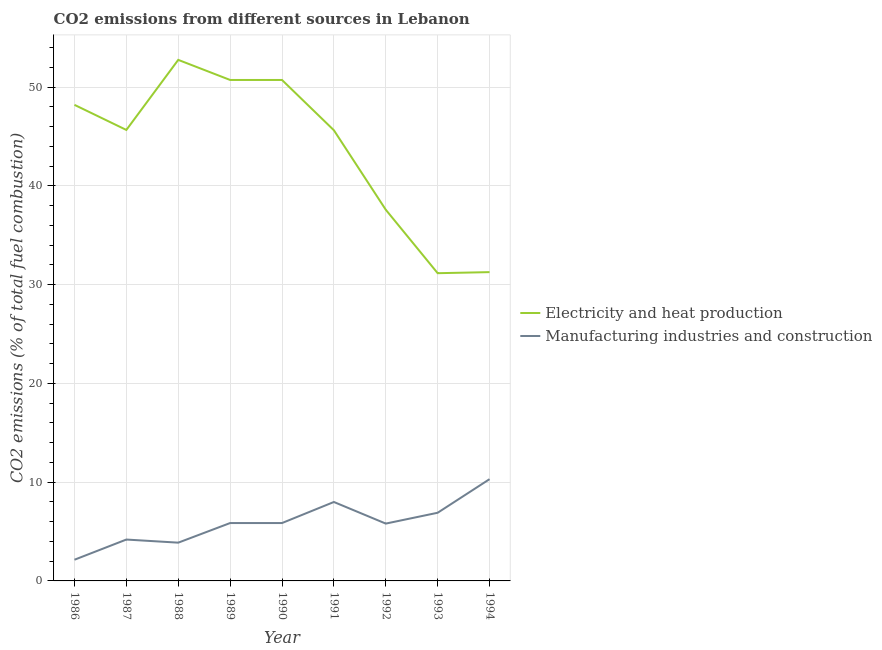How many different coloured lines are there?
Offer a very short reply. 2. Does the line corresponding to co2 emissions due to manufacturing industries intersect with the line corresponding to co2 emissions due to electricity and heat production?
Ensure brevity in your answer.  No. Is the number of lines equal to the number of legend labels?
Your answer should be very brief. Yes. What is the co2 emissions due to electricity and heat production in 1988?
Offer a terse response. 52.77. Across all years, what is the maximum co2 emissions due to manufacturing industries?
Give a very brief answer. 10.3. Across all years, what is the minimum co2 emissions due to electricity and heat production?
Your response must be concise. 31.16. What is the total co2 emissions due to electricity and heat production in the graph?
Give a very brief answer. 393.78. What is the difference between the co2 emissions due to electricity and heat production in 1991 and that in 1992?
Offer a very short reply. 8.05. What is the difference between the co2 emissions due to electricity and heat production in 1990 and the co2 emissions due to manufacturing industries in 1986?
Make the answer very short. 48.59. What is the average co2 emissions due to electricity and heat production per year?
Keep it short and to the point. 43.75. In the year 1994, what is the difference between the co2 emissions due to manufacturing industries and co2 emissions due to electricity and heat production?
Make the answer very short. -20.97. In how many years, is the co2 emissions due to electricity and heat production greater than 44 %?
Ensure brevity in your answer.  6. What is the ratio of the co2 emissions due to manufacturing industries in 1989 to that in 1993?
Provide a succinct answer. 0.85. Is the difference between the co2 emissions due to manufacturing industries in 1986 and 1992 greater than the difference between the co2 emissions due to electricity and heat production in 1986 and 1992?
Your response must be concise. No. What is the difference between the highest and the second highest co2 emissions due to electricity and heat production?
Provide a succinct answer. 2.03. What is the difference between the highest and the lowest co2 emissions due to electricity and heat production?
Provide a short and direct response. 21.6. In how many years, is the co2 emissions due to electricity and heat production greater than the average co2 emissions due to electricity and heat production taken over all years?
Give a very brief answer. 6. Is the sum of the co2 emissions due to manufacturing industries in 1990 and 1993 greater than the maximum co2 emissions due to electricity and heat production across all years?
Make the answer very short. No. Is the co2 emissions due to electricity and heat production strictly greater than the co2 emissions due to manufacturing industries over the years?
Your answer should be very brief. Yes. Is the co2 emissions due to electricity and heat production strictly less than the co2 emissions due to manufacturing industries over the years?
Ensure brevity in your answer.  No. Are the values on the major ticks of Y-axis written in scientific E-notation?
Your answer should be very brief. No. Does the graph contain grids?
Give a very brief answer. Yes. Where does the legend appear in the graph?
Make the answer very short. Center right. How are the legend labels stacked?
Your answer should be very brief. Vertical. What is the title of the graph?
Offer a terse response. CO2 emissions from different sources in Lebanon. What is the label or title of the X-axis?
Ensure brevity in your answer.  Year. What is the label or title of the Y-axis?
Your response must be concise. CO2 emissions (% of total fuel combustion). What is the CO2 emissions (% of total fuel combustion) of Electricity and heat production in 1986?
Provide a short and direct response. 48.21. What is the CO2 emissions (% of total fuel combustion) of Manufacturing industries and construction in 1986?
Your response must be concise. 2.15. What is the CO2 emissions (% of total fuel combustion) in Electricity and heat production in 1987?
Offer a terse response. 45.67. What is the CO2 emissions (% of total fuel combustion) of Manufacturing industries and construction in 1987?
Your answer should be very brief. 4.19. What is the CO2 emissions (% of total fuel combustion) of Electricity and heat production in 1988?
Provide a succinct answer. 52.77. What is the CO2 emissions (% of total fuel combustion) in Manufacturing industries and construction in 1988?
Your answer should be compact. 3.87. What is the CO2 emissions (% of total fuel combustion) in Electricity and heat production in 1989?
Your answer should be compact. 50.73. What is the CO2 emissions (% of total fuel combustion) of Manufacturing industries and construction in 1989?
Offer a terse response. 5.86. What is the CO2 emissions (% of total fuel combustion) of Electricity and heat production in 1990?
Make the answer very short. 50.73. What is the CO2 emissions (% of total fuel combustion) in Manufacturing industries and construction in 1990?
Offer a very short reply. 5.86. What is the CO2 emissions (% of total fuel combustion) of Electricity and heat production in 1991?
Offer a very short reply. 45.64. What is the CO2 emissions (% of total fuel combustion) in Manufacturing industries and construction in 1991?
Offer a terse response. 7.99. What is the CO2 emissions (% of total fuel combustion) of Electricity and heat production in 1992?
Give a very brief answer. 37.59. What is the CO2 emissions (% of total fuel combustion) in Manufacturing industries and construction in 1992?
Your answer should be very brief. 5.81. What is the CO2 emissions (% of total fuel combustion) in Electricity and heat production in 1993?
Your response must be concise. 31.16. What is the CO2 emissions (% of total fuel combustion) in Manufacturing industries and construction in 1993?
Keep it short and to the point. 6.9. What is the CO2 emissions (% of total fuel combustion) in Electricity and heat production in 1994?
Keep it short and to the point. 31.27. What is the CO2 emissions (% of total fuel combustion) of Manufacturing industries and construction in 1994?
Your answer should be compact. 10.3. Across all years, what is the maximum CO2 emissions (% of total fuel combustion) of Electricity and heat production?
Offer a terse response. 52.77. Across all years, what is the maximum CO2 emissions (% of total fuel combustion) in Manufacturing industries and construction?
Provide a short and direct response. 10.3. Across all years, what is the minimum CO2 emissions (% of total fuel combustion) in Electricity and heat production?
Offer a very short reply. 31.16. Across all years, what is the minimum CO2 emissions (% of total fuel combustion) in Manufacturing industries and construction?
Make the answer very short. 2.15. What is the total CO2 emissions (% of total fuel combustion) of Electricity and heat production in the graph?
Provide a short and direct response. 393.78. What is the total CO2 emissions (% of total fuel combustion) of Manufacturing industries and construction in the graph?
Provide a short and direct response. 52.94. What is the difference between the CO2 emissions (% of total fuel combustion) of Electricity and heat production in 1986 and that in 1987?
Make the answer very short. 2.54. What is the difference between the CO2 emissions (% of total fuel combustion) of Manufacturing industries and construction in 1986 and that in 1987?
Your response must be concise. -2.04. What is the difference between the CO2 emissions (% of total fuel combustion) of Electricity and heat production in 1986 and that in 1988?
Provide a succinct answer. -4.56. What is the difference between the CO2 emissions (% of total fuel combustion) in Manufacturing industries and construction in 1986 and that in 1988?
Your answer should be very brief. -1.73. What is the difference between the CO2 emissions (% of total fuel combustion) of Electricity and heat production in 1986 and that in 1989?
Keep it short and to the point. -2.52. What is the difference between the CO2 emissions (% of total fuel combustion) of Manufacturing industries and construction in 1986 and that in 1989?
Your answer should be compact. -3.71. What is the difference between the CO2 emissions (% of total fuel combustion) of Electricity and heat production in 1986 and that in 1990?
Your response must be concise. -2.52. What is the difference between the CO2 emissions (% of total fuel combustion) of Manufacturing industries and construction in 1986 and that in 1990?
Give a very brief answer. -3.71. What is the difference between the CO2 emissions (% of total fuel combustion) of Electricity and heat production in 1986 and that in 1991?
Your response must be concise. 2.57. What is the difference between the CO2 emissions (% of total fuel combustion) of Manufacturing industries and construction in 1986 and that in 1991?
Ensure brevity in your answer.  -5.85. What is the difference between the CO2 emissions (% of total fuel combustion) of Electricity and heat production in 1986 and that in 1992?
Your response must be concise. 10.62. What is the difference between the CO2 emissions (% of total fuel combustion) of Manufacturing industries and construction in 1986 and that in 1992?
Your answer should be compact. -3.66. What is the difference between the CO2 emissions (% of total fuel combustion) in Electricity and heat production in 1986 and that in 1993?
Ensure brevity in your answer.  17.05. What is the difference between the CO2 emissions (% of total fuel combustion) in Manufacturing industries and construction in 1986 and that in 1993?
Ensure brevity in your answer.  -4.76. What is the difference between the CO2 emissions (% of total fuel combustion) in Electricity and heat production in 1986 and that in 1994?
Your answer should be compact. 16.94. What is the difference between the CO2 emissions (% of total fuel combustion) in Manufacturing industries and construction in 1986 and that in 1994?
Give a very brief answer. -8.16. What is the difference between the CO2 emissions (% of total fuel combustion) of Electricity and heat production in 1987 and that in 1988?
Provide a short and direct response. -7.1. What is the difference between the CO2 emissions (% of total fuel combustion) in Manufacturing industries and construction in 1987 and that in 1988?
Keep it short and to the point. 0.32. What is the difference between the CO2 emissions (% of total fuel combustion) in Electricity and heat production in 1987 and that in 1989?
Your answer should be very brief. -5.06. What is the difference between the CO2 emissions (% of total fuel combustion) of Manufacturing industries and construction in 1987 and that in 1989?
Offer a very short reply. -1.67. What is the difference between the CO2 emissions (% of total fuel combustion) in Electricity and heat production in 1987 and that in 1990?
Your answer should be very brief. -5.06. What is the difference between the CO2 emissions (% of total fuel combustion) of Manufacturing industries and construction in 1987 and that in 1990?
Provide a succinct answer. -1.67. What is the difference between the CO2 emissions (% of total fuel combustion) of Electricity and heat production in 1987 and that in 1991?
Your answer should be compact. 0.03. What is the difference between the CO2 emissions (% of total fuel combustion) in Manufacturing industries and construction in 1987 and that in 1991?
Keep it short and to the point. -3.8. What is the difference between the CO2 emissions (% of total fuel combustion) of Electricity and heat production in 1987 and that in 1992?
Offer a very short reply. 8.08. What is the difference between the CO2 emissions (% of total fuel combustion) in Manufacturing industries and construction in 1987 and that in 1992?
Your answer should be very brief. -1.62. What is the difference between the CO2 emissions (% of total fuel combustion) in Electricity and heat production in 1987 and that in 1993?
Your response must be concise. 14.51. What is the difference between the CO2 emissions (% of total fuel combustion) in Manufacturing industries and construction in 1987 and that in 1993?
Your answer should be very brief. -2.71. What is the difference between the CO2 emissions (% of total fuel combustion) in Electricity and heat production in 1987 and that in 1994?
Your answer should be very brief. 14.4. What is the difference between the CO2 emissions (% of total fuel combustion) in Manufacturing industries and construction in 1987 and that in 1994?
Your answer should be very brief. -6.11. What is the difference between the CO2 emissions (% of total fuel combustion) in Electricity and heat production in 1988 and that in 1989?
Provide a short and direct response. 2.03. What is the difference between the CO2 emissions (% of total fuel combustion) in Manufacturing industries and construction in 1988 and that in 1989?
Your answer should be very brief. -1.99. What is the difference between the CO2 emissions (% of total fuel combustion) in Electricity and heat production in 1988 and that in 1990?
Give a very brief answer. 2.03. What is the difference between the CO2 emissions (% of total fuel combustion) of Manufacturing industries and construction in 1988 and that in 1990?
Offer a very short reply. -1.99. What is the difference between the CO2 emissions (% of total fuel combustion) in Electricity and heat production in 1988 and that in 1991?
Offer a very short reply. 7.13. What is the difference between the CO2 emissions (% of total fuel combustion) of Manufacturing industries and construction in 1988 and that in 1991?
Offer a very short reply. -4.12. What is the difference between the CO2 emissions (% of total fuel combustion) of Electricity and heat production in 1988 and that in 1992?
Ensure brevity in your answer.  15.18. What is the difference between the CO2 emissions (% of total fuel combustion) of Manufacturing industries and construction in 1988 and that in 1992?
Give a very brief answer. -1.93. What is the difference between the CO2 emissions (% of total fuel combustion) in Electricity and heat production in 1988 and that in 1993?
Keep it short and to the point. 21.6. What is the difference between the CO2 emissions (% of total fuel combustion) in Manufacturing industries and construction in 1988 and that in 1993?
Your response must be concise. -3.03. What is the difference between the CO2 emissions (% of total fuel combustion) of Electricity and heat production in 1988 and that in 1994?
Provide a short and direct response. 21.5. What is the difference between the CO2 emissions (% of total fuel combustion) of Manufacturing industries and construction in 1988 and that in 1994?
Offer a very short reply. -6.43. What is the difference between the CO2 emissions (% of total fuel combustion) of Electricity and heat production in 1989 and that in 1991?
Give a very brief answer. 5.09. What is the difference between the CO2 emissions (% of total fuel combustion) of Manufacturing industries and construction in 1989 and that in 1991?
Give a very brief answer. -2.13. What is the difference between the CO2 emissions (% of total fuel combustion) of Electricity and heat production in 1989 and that in 1992?
Give a very brief answer. 13.14. What is the difference between the CO2 emissions (% of total fuel combustion) of Manufacturing industries and construction in 1989 and that in 1992?
Provide a succinct answer. 0.06. What is the difference between the CO2 emissions (% of total fuel combustion) of Electricity and heat production in 1989 and that in 1993?
Give a very brief answer. 19.57. What is the difference between the CO2 emissions (% of total fuel combustion) in Manufacturing industries and construction in 1989 and that in 1993?
Your answer should be very brief. -1.04. What is the difference between the CO2 emissions (% of total fuel combustion) in Electricity and heat production in 1989 and that in 1994?
Your answer should be very brief. 19.46. What is the difference between the CO2 emissions (% of total fuel combustion) of Manufacturing industries and construction in 1989 and that in 1994?
Provide a short and direct response. -4.44. What is the difference between the CO2 emissions (% of total fuel combustion) of Electricity and heat production in 1990 and that in 1991?
Offer a very short reply. 5.09. What is the difference between the CO2 emissions (% of total fuel combustion) in Manufacturing industries and construction in 1990 and that in 1991?
Give a very brief answer. -2.13. What is the difference between the CO2 emissions (% of total fuel combustion) of Electricity and heat production in 1990 and that in 1992?
Make the answer very short. 13.14. What is the difference between the CO2 emissions (% of total fuel combustion) of Manufacturing industries and construction in 1990 and that in 1992?
Provide a succinct answer. 0.06. What is the difference between the CO2 emissions (% of total fuel combustion) in Electricity and heat production in 1990 and that in 1993?
Your response must be concise. 19.57. What is the difference between the CO2 emissions (% of total fuel combustion) of Manufacturing industries and construction in 1990 and that in 1993?
Your answer should be compact. -1.04. What is the difference between the CO2 emissions (% of total fuel combustion) in Electricity and heat production in 1990 and that in 1994?
Your answer should be very brief. 19.46. What is the difference between the CO2 emissions (% of total fuel combustion) in Manufacturing industries and construction in 1990 and that in 1994?
Give a very brief answer. -4.44. What is the difference between the CO2 emissions (% of total fuel combustion) in Electricity and heat production in 1991 and that in 1992?
Your response must be concise. 8.05. What is the difference between the CO2 emissions (% of total fuel combustion) of Manufacturing industries and construction in 1991 and that in 1992?
Keep it short and to the point. 2.19. What is the difference between the CO2 emissions (% of total fuel combustion) of Electricity and heat production in 1991 and that in 1993?
Make the answer very short. 14.48. What is the difference between the CO2 emissions (% of total fuel combustion) of Manufacturing industries and construction in 1991 and that in 1993?
Provide a succinct answer. 1.09. What is the difference between the CO2 emissions (% of total fuel combustion) of Electricity and heat production in 1991 and that in 1994?
Your answer should be very brief. 14.37. What is the difference between the CO2 emissions (% of total fuel combustion) of Manufacturing industries and construction in 1991 and that in 1994?
Offer a very short reply. -2.31. What is the difference between the CO2 emissions (% of total fuel combustion) in Electricity and heat production in 1992 and that in 1993?
Your answer should be compact. 6.43. What is the difference between the CO2 emissions (% of total fuel combustion) of Manufacturing industries and construction in 1992 and that in 1993?
Keep it short and to the point. -1.1. What is the difference between the CO2 emissions (% of total fuel combustion) in Electricity and heat production in 1992 and that in 1994?
Your answer should be compact. 6.32. What is the difference between the CO2 emissions (% of total fuel combustion) of Manufacturing industries and construction in 1992 and that in 1994?
Offer a terse response. -4.5. What is the difference between the CO2 emissions (% of total fuel combustion) of Electricity and heat production in 1993 and that in 1994?
Provide a succinct answer. -0.11. What is the difference between the CO2 emissions (% of total fuel combustion) of Manufacturing industries and construction in 1993 and that in 1994?
Provide a short and direct response. -3.4. What is the difference between the CO2 emissions (% of total fuel combustion) of Electricity and heat production in 1986 and the CO2 emissions (% of total fuel combustion) of Manufacturing industries and construction in 1987?
Ensure brevity in your answer.  44.02. What is the difference between the CO2 emissions (% of total fuel combustion) of Electricity and heat production in 1986 and the CO2 emissions (% of total fuel combustion) of Manufacturing industries and construction in 1988?
Keep it short and to the point. 44.34. What is the difference between the CO2 emissions (% of total fuel combustion) of Electricity and heat production in 1986 and the CO2 emissions (% of total fuel combustion) of Manufacturing industries and construction in 1989?
Offer a very short reply. 42.35. What is the difference between the CO2 emissions (% of total fuel combustion) of Electricity and heat production in 1986 and the CO2 emissions (% of total fuel combustion) of Manufacturing industries and construction in 1990?
Offer a terse response. 42.35. What is the difference between the CO2 emissions (% of total fuel combustion) of Electricity and heat production in 1986 and the CO2 emissions (% of total fuel combustion) of Manufacturing industries and construction in 1991?
Your answer should be compact. 40.22. What is the difference between the CO2 emissions (% of total fuel combustion) in Electricity and heat production in 1986 and the CO2 emissions (% of total fuel combustion) in Manufacturing industries and construction in 1992?
Keep it short and to the point. 42.41. What is the difference between the CO2 emissions (% of total fuel combustion) in Electricity and heat production in 1986 and the CO2 emissions (% of total fuel combustion) in Manufacturing industries and construction in 1993?
Ensure brevity in your answer.  41.31. What is the difference between the CO2 emissions (% of total fuel combustion) in Electricity and heat production in 1986 and the CO2 emissions (% of total fuel combustion) in Manufacturing industries and construction in 1994?
Offer a very short reply. 37.91. What is the difference between the CO2 emissions (% of total fuel combustion) of Electricity and heat production in 1987 and the CO2 emissions (% of total fuel combustion) of Manufacturing industries and construction in 1988?
Offer a very short reply. 41.8. What is the difference between the CO2 emissions (% of total fuel combustion) in Electricity and heat production in 1987 and the CO2 emissions (% of total fuel combustion) in Manufacturing industries and construction in 1989?
Give a very brief answer. 39.81. What is the difference between the CO2 emissions (% of total fuel combustion) in Electricity and heat production in 1987 and the CO2 emissions (% of total fuel combustion) in Manufacturing industries and construction in 1990?
Make the answer very short. 39.81. What is the difference between the CO2 emissions (% of total fuel combustion) in Electricity and heat production in 1987 and the CO2 emissions (% of total fuel combustion) in Manufacturing industries and construction in 1991?
Provide a succinct answer. 37.68. What is the difference between the CO2 emissions (% of total fuel combustion) in Electricity and heat production in 1987 and the CO2 emissions (% of total fuel combustion) in Manufacturing industries and construction in 1992?
Your answer should be very brief. 39.86. What is the difference between the CO2 emissions (% of total fuel combustion) in Electricity and heat production in 1987 and the CO2 emissions (% of total fuel combustion) in Manufacturing industries and construction in 1993?
Keep it short and to the point. 38.77. What is the difference between the CO2 emissions (% of total fuel combustion) of Electricity and heat production in 1987 and the CO2 emissions (% of total fuel combustion) of Manufacturing industries and construction in 1994?
Give a very brief answer. 35.37. What is the difference between the CO2 emissions (% of total fuel combustion) of Electricity and heat production in 1988 and the CO2 emissions (% of total fuel combustion) of Manufacturing industries and construction in 1989?
Your response must be concise. 46.91. What is the difference between the CO2 emissions (% of total fuel combustion) in Electricity and heat production in 1988 and the CO2 emissions (% of total fuel combustion) in Manufacturing industries and construction in 1990?
Provide a succinct answer. 46.91. What is the difference between the CO2 emissions (% of total fuel combustion) of Electricity and heat production in 1988 and the CO2 emissions (% of total fuel combustion) of Manufacturing industries and construction in 1991?
Make the answer very short. 44.77. What is the difference between the CO2 emissions (% of total fuel combustion) in Electricity and heat production in 1988 and the CO2 emissions (% of total fuel combustion) in Manufacturing industries and construction in 1992?
Offer a terse response. 46.96. What is the difference between the CO2 emissions (% of total fuel combustion) in Electricity and heat production in 1988 and the CO2 emissions (% of total fuel combustion) in Manufacturing industries and construction in 1993?
Ensure brevity in your answer.  45.86. What is the difference between the CO2 emissions (% of total fuel combustion) in Electricity and heat production in 1988 and the CO2 emissions (% of total fuel combustion) in Manufacturing industries and construction in 1994?
Give a very brief answer. 42.46. What is the difference between the CO2 emissions (% of total fuel combustion) of Electricity and heat production in 1989 and the CO2 emissions (% of total fuel combustion) of Manufacturing industries and construction in 1990?
Your answer should be compact. 44.87. What is the difference between the CO2 emissions (% of total fuel combustion) in Electricity and heat production in 1989 and the CO2 emissions (% of total fuel combustion) in Manufacturing industries and construction in 1991?
Keep it short and to the point. 42.74. What is the difference between the CO2 emissions (% of total fuel combustion) of Electricity and heat production in 1989 and the CO2 emissions (% of total fuel combustion) of Manufacturing industries and construction in 1992?
Your answer should be compact. 44.93. What is the difference between the CO2 emissions (% of total fuel combustion) in Electricity and heat production in 1989 and the CO2 emissions (% of total fuel combustion) in Manufacturing industries and construction in 1993?
Your response must be concise. 43.83. What is the difference between the CO2 emissions (% of total fuel combustion) of Electricity and heat production in 1989 and the CO2 emissions (% of total fuel combustion) of Manufacturing industries and construction in 1994?
Your response must be concise. 40.43. What is the difference between the CO2 emissions (% of total fuel combustion) in Electricity and heat production in 1990 and the CO2 emissions (% of total fuel combustion) in Manufacturing industries and construction in 1991?
Offer a very short reply. 42.74. What is the difference between the CO2 emissions (% of total fuel combustion) in Electricity and heat production in 1990 and the CO2 emissions (% of total fuel combustion) in Manufacturing industries and construction in 1992?
Ensure brevity in your answer.  44.93. What is the difference between the CO2 emissions (% of total fuel combustion) in Electricity and heat production in 1990 and the CO2 emissions (% of total fuel combustion) in Manufacturing industries and construction in 1993?
Give a very brief answer. 43.83. What is the difference between the CO2 emissions (% of total fuel combustion) of Electricity and heat production in 1990 and the CO2 emissions (% of total fuel combustion) of Manufacturing industries and construction in 1994?
Provide a short and direct response. 40.43. What is the difference between the CO2 emissions (% of total fuel combustion) in Electricity and heat production in 1991 and the CO2 emissions (% of total fuel combustion) in Manufacturing industries and construction in 1992?
Ensure brevity in your answer.  39.83. What is the difference between the CO2 emissions (% of total fuel combustion) of Electricity and heat production in 1991 and the CO2 emissions (% of total fuel combustion) of Manufacturing industries and construction in 1993?
Keep it short and to the point. 38.74. What is the difference between the CO2 emissions (% of total fuel combustion) in Electricity and heat production in 1991 and the CO2 emissions (% of total fuel combustion) in Manufacturing industries and construction in 1994?
Your answer should be very brief. 35.33. What is the difference between the CO2 emissions (% of total fuel combustion) of Electricity and heat production in 1992 and the CO2 emissions (% of total fuel combustion) of Manufacturing industries and construction in 1993?
Provide a short and direct response. 30.69. What is the difference between the CO2 emissions (% of total fuel combustion) of Electricity and heat production in 1992 and the CO2 emissions (% of total fuel combustion) of Manufacturing industries and construction in 1994?
Ensure brevity in your answer.  27.29. What is the difference between the CO2 emissions (% of total fuel combustion) in Electricity and heat production in 1993 and the CO2 emissions (% of total fuel combustion) in Manufacturing industries and construction in 1994?
Your answer should be very brief. 20.86. What is the average CO2 emissions (% of total fuel combustion) of Electricity and heat production per year?
Your answer should be compact. 43.75. What is the average CO2 emissions (% of total fuel combustion) of Manufacturing industries and construction per year?
Provide a short and direct response. 5.88. In the year 1986, what is the difference between the CO2 emissions (% of total fuel combustion) in Electricity and heat production and CO2 emissions (% of total fuel combustion) in Manufacturing industries and construction?
Provide a succinct answer. 46.07. In the year 1987, what is the difference between the CO2 emissions (% of total fuel combustion) in Electricity and heat production and CO2 emissions (% of total fuel combustion) in Manufacturing industries and construction?
Your answer should be very brief. 41.48. In the year 1988, what is the difference between the CO2 emissions (% of total fuel combustion) of Electricity and heat production and CO2 emissions (% of total fuel combustion) of Manufacturing industries and construction?
Offer a very short reply. 48.89. In the year 1989, what is the difference between the CO2 emissions (% of total fuel combustion) in Electricity and heat production and CO2 emissions (% of total fuel combustion) in Manufacturing industries and construction?
Offer a terse response. 44.87. In the year 1990, what is the difference between the CO2 emissions (% of total fuel combustion) in Electricity and heat production and CO2 emissions (% of total fuel combustion) in Manufacturing industries and construction?
Ensure brevity in your answer.  44.87. In the year 1991, what is the difference between the CO2 emissions (% of total fuel combustion) in Electricity and heat production and CO2 emissions (% of total fuel combustion) in Manufacturing industries and construction?
Keep it short and to the point. 37.65. In the year 1992, what is the difference between the CO2 emissions (% of total fuel combustion) of Electricity and heat production and CO2 emissions (% of total fuel combustion) of Manufacturing industries and construction?
Offer a terse response. 31.79. In the year 1993, what is the difference between the CO2 emissions (% of total fuel combustion) in Electricity and heat production and CO2 emissions (% of total fuel combustion) in Manufacturing industries and construction?
Give a very brief answer. 24.26. In the year 1994, what is the difference between the CO2 emissions (% of total fuel combustion) in Electricity and heat production and CO2 emissions (% of total fuel combustion) in Manufacturing industries and construction?
Your answer should be very brief. 20.97. What is the ratio of the CO2 emissions (% of total fuel combustion) in Electricity and heat production in 1986 to that in 1987?
Your answer should be very brief. 1.06. What is the ratio of the CO2 emissions (% of total fuel combustion) in Manufacturing industries and construction in 1986 to that in 1987?
Provide a succinct answer. 0.51. What is the ratio of the CO2 emissions (% of total fuel combustion) of Electricity and heat production in 1986 to that in 1988?
Your answer should be compact. 0.91. What is the ratio of the CO2 emissions (% of total fuel combustion) of Manufacturing industries and construction in 1986 to that in 1988?
Ensure brevity in your answer.  0.55. What is the ratio of the CO2 emissions (% of total fuel combustion) in Electricity and heat production in 1986 to that in 1989?
Your answer should be very brief. 0.95. What is the ratio of the CO2 emissions (% of total fuel combustion) in Manufacturing industries and construction in 1986 to that in 1989?
Give a very brief answer. 0.37. What is the ratio of the CO2 emissions (% of total fuel combustion) in Electricity and heat production in 1986 to that in 1990?
Give a very brief answer. 0.95. What is the ratio of the CO2 emissions (% of total fuel combustion) in Manufacturing industries and construction in 1986 to that in 1990?
Make the answer very short. 0.37. What is the ratio of the CO2 emissions (% of total fuel combustion) of Electricity and heat production in 1986 to that in 1991?
Offer a very short reply. 1.06. What is the ratio of the CO2 emissions (% of total fuel combustion) in Manufacturing industries and construction in 1986 to that in 1991?
Your response must be concise. 0.27. What is the ratio of the CO2 emissions (% of total fuel combustion) in Electricity and heat production in 1986 to that in 1992?
Your response must be concise. 1.28. What is the ratio of the CO2 emissions (% of total fuel combustion) of Manufacturing industries and construction in 1986 to that in 1992?
Keep it short and to the point. 0.37. What is the ratio of the CO2 emissions (% of total fuel combustion) in Electricity and heat production in 1986 to that in 1993?
Your answer should be very brief. 1.55. What is the ratio of the CO2 emissions (% of total fuel combustion) in Manufacturing industries and construction in 1986 to that in 1993?
Your answer should be compact. 0.31. What is the ratio of the CO2 emissions (% of total fuel combustion) in Electricity and heat production in 1986 to that in 1994?
Keep it short and to the point. 1.54. What is the ratio of the CO2 emissions (% of total fuel combustion) in Manufacturing industries and construction in 1986 to that in 1994?
Offer a very short reply. 0.21. What is the ratio of the CO2 emissions (% of total fuel combustion) of Electricity and heat production in 1987 to that in 1988?
Ensure brevity in your answer.  0.87. What is the ratio of the CO2 emissions (% of total fuel combustion) of Manufacturing industries and construction in 1987 to that in 1988?
Your response must be concise. 1.08. What is the ratio of the CO2 emissions (% of total fuel combustion) in Electricity and heat production in 1987 to that in 1989?
Make the answer very short. 0.9. What is the ratio of the CO2 emissions (% of total fuel combustion) of Manufacturing industries and construction in 1987 to that in 1989?
Make the answer very short. 0.71. What is the ratio of the CO2 emissions (% of total fuel combustion) in Electricity and heat production in 1987 to that in 1990?
Your answer should be very brief. 0.9. What is the ratio of the CO2 emissions (% of total fuel combustion) in Manufacturing industries and construction in 1987 to that in 1990?
Offer a terse response. 0.71. What is the ratio of the CO2 emissions (% of total fuel combustion) in Electricity and heat production in 1987 to that in 1991?
Your answer should be very brief. 1. What is the ratio of the CO2 emissions (% of total fuel combustion) of Manufacturing industries and construction in 1987 to that in 1991?
Your answer should be compact. 0.52. What is the ratio of the CO2 emissions (% of total fuel combustion) in Electricity and heat production in 1987 to that in 1992?
Provide a short and direct response. 1.21. What is the ratio of the CO2 emissions (% of total fuel combustion) of Manufacturing industries and construction in 1987 to that in 1992?
Ensure brevity in your answer.  0.72. What is the ratio of the CO2 emissions (% of total fuel combustion) of Electricity and heat production in 1987 to that in 1993?
Keep it short and to the point. 1.47. What is the ratio of the CO2 emissions (% of total fuel combustion) in Manufacturing industries and construction in 1987 to that in 1993?
Give a very brief answer. 0.61. What is the ratio of the CO2 emissions (% of total fuel combustion) of Electricity and heat production in 1987 to that in 1994?
Your answer should be compact. 1.46. What is the ratio of the CO2 emissions (% of total fuel combustion) of Manufacturing industries and construction in 1987 to that in 1994?
Your answer should be compact. 0.41. What is the ratio of the CO2 emissions (% of total fuel combustion) in Electricity and heat production in 1988 to that in 1989?
Your answer should be very brief. 1.04. What is the ratio of the CO2 emissions (% of total fuel combustion) of Manufacturing industries and construction in 1988 to that in 1989?
Make the answer very short. 0.66. What is the ratio of the CO2 emissions (% of total fuel combustion) in Electricity and heat production in 1988 to that in 1990?
Offer a terse response. 1.04. What is the ratio of the CO2 emissions (% of total fuel combustion) of Manufacturing industries and construction in 1988 to that in 1990?
Provide a short and direct response. 0.66. What is the ratio of the CO2 emissions (% of total fuel combustion) of Electricity and heat production in 1988 to that in 1991?
Provide a succinct answer. 1.16. What is the ratio of the CO2 emissions (% of total fuel combustion) in Manufacturing industries and construction in 1988 to that in 1991?
Keep it short and to the point. 0.48. What is the ratio of the CO2 emissions (% of total fuel combustion) of Electricity and heat production in 1988 to that in 1992?
Your answer should be very brief. 1.4. What is the ratio of the CO2 emissions (% of total fuel combustion) in Manufacturing industries and construction in 1988 to that in 1992?
Offer a terse response. 0.67. What is the ratio of the CO2 emissions (% of total fuel combustion) in Electricity and heat production in 1988 to that in 1993?
Your answer should be very brief. 1.69. What is the ratio of the CO2 emissions (% of total fuel combustion) in Manufacturing industries and construction in 1988 to that in 1993?
Offer a very short reply. 0.56. What is the ratio of the CO2 emissions (% of total fuel combustion) in Electricity and heat production in 1988 to that in 1994?
Provide a succinct answer. 1.69. What is the ratio of the CO2 emissions (% of total fuel combustion) in Manufacturing industries and construction in 1988 to that in 1994?
Give a very brief answer. 0.38. What is the ratio of the CO2 emissions (% of total fuel combustion) of Electricity and heat production in 1989 to that in 1990?
Keep it short and to the point. 1. What is the ratio of the CO2 emissions (% of total fuel combustion) in Electricity and heat production in 1989 to that in 1991?
Give a very brief answer. 1.11. What is the ratio of the CO2 emissions (% of total fuel combustion) in Manufacturing industries and construction in 1989 to that in 1991?
Give a very brief answer. 0.73. What is the ratio of the CO2 emissions (% of total fuel combustion) of Electricity and heat production in 1989 to that in 1992?
Keep it short and to the point. 1.35. What is the ratio of the CO2 emissions (% of total fuel combustion) in Manufacturing industries and construction in 1989 to that in 1992?
Ensure brevity in your answer.  1.01. What is the ratio of the CO2 emissions (% of total fuel combustion) in Electricity and heat production in 1989 to that in 1993?
Give a very brief answer. 1.63. What is the ratio of the CO2 emissions (% of total fuel combustion) in Manufacturing industries and construction in 1989 to that in 1993?
Keep it short and to the point. 0.85. What is the ratio of the CO2 emissions (% of total fuel combustion) of Electricity and heat production in 1989 to that in 1994?
Your response must be concise. 1.62. What is the ratio of the CO2 emissions (% of total fuel combustion) of Manufacturing industries and construction in 1989 to that in 1994?
Offer a terse response. 0.57. What is the ratio of the CO2 emissions (% of total fuel combustion) of Electricity and heat production in 1990 to that in 1991?
Keep it short and to the point. 1.11. What is the ratio of the CO2 emissions (% of total fuel combustion) in Manufacturing industries and construction in 1990 to that in 1991?
Your answer should be compact. 0.73. What is the ratio of the CO2 emissions (% of total fuel combustion) in Electricity and heat production in 1990 to that in 1992?
Your answer should be very brief. 1.35. What is the ratio of the CO2 emissions (% of total fuel combustion) in Manufacturing industries and construction in 1990 to that in 1992?
Keep it short and to the point. 1.01. What is the ratio of the CO2 emissions (% of total fuel combustion) in Electricity and heat production in 1990 to that in 1993?
Provide a short and direct response. 1.63. What is the ratio of the CO2 emissions (% of total fuel combustion) in Manufacturing industries and construction in 1990 to that in 1993?
Your answer should be compact. 0.85. What is the ratio of the CO2 emissions (% of total fuel combustion) of Electricity and heat production in 1990 to that in 1994?
Your answer should be compact. 1.62. What is the ratio of the CO2 emissions (% of total fuel combustion) of Manufacturing industries and construction in 1990 to that in 1994?
Provide a short and direct response. 0.57. What is the ratio of the CO2 emissions (% of total fuel combustion) of Electricity and heat production in 1991 to that in 1992?
Your answer should be compact. 1.21. What is the ratio of the CO2 emissions (% of total fuel combustion) in Manufacturing industries and construction in 1991 to that in 1992?
Offer a very short reply. 1.38. What is the ratio of the CO2 emissions (% of total fuel combustion) of Electricity and heat production in 1991 to that in 1993?
Provide a succinct answer. 1.46. What is the ratio of the CO2 emissions (% of total fuel combustion) of Manufacturing industries and construction in 1991 to that in 1993?
Offer a terse response. 1.16. What is the ratio of the CO2 emissions (% of total fuel combustion) of Electricity and heat production in 1991 to that in 1994?
Offer a terse response. 1.46. What is the ratio of the CO2 emissions (% of total fuel combustion) of Manufacturing industries and construction in 1991 to that in 1994?
Your answer should be compact. 0.78. What is the ratio of the CO2 emissions (% of total fuel combustion) in Electricity and heat production in 1992 to that in 1993?
Your answer should be very brief. 1.21. What is the ratio of the CO2 emissions (% of total fuel combustion) of Manufacturing industries and construction in 1992 to that in 1993?
Provide a short and direct response. 0.84. What is the ratio of the CO2 emissions (% of total fuel combustion) of Electricity and heat production in 1992 to that in 1994?
Keep it short and to the point. 1.2. What is the ratio of the CO2 emissions (% of total fuel combustion) of Manufacturing industries and construction in 1992 to that in 1994?
Offer a terse response. 0.56. What is the ratio of the CO2 emissions (% of total fuel combustion) of Manufacturing industries and construction in 1993 to that in 1994?
Keep it short and to the point. 0.67. What is the difference between the highest and the second highest CO2 emissions (% of total fuel combustion) of Electricity and heat production?
Offer a very short reply. 2.03. What is the difference between the highest and the second highest CO2 emissions (% of total fuel combustion) in Manufacturing industries and construction?
Keep it short and to the point. 2.31. What is the difference between the highest and the lowest CO2 emissions (% of total fuel combustion) in Electricity and heat production?
Offer a terse response. 21.6. What is the difference between the highest and the lowest CO2 emissions (% of total fuel combustion) of Manufacturing industries and construction?
Give a very brief answer. 8.16. 